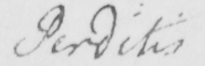Can you read and transcribe this handwriting? Perditis 